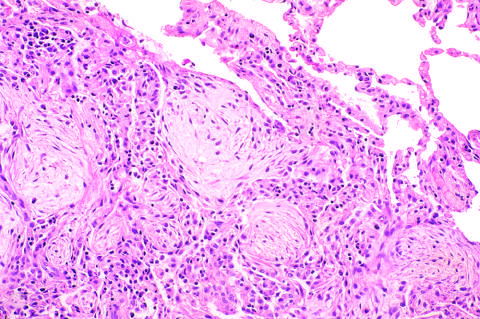does advanced organizing pneumonia feature transformation of exudates to fibromyxoid masses infiltrated by macrophages and fibroblasts?
Answer the question using a single word or phrase. Yes 